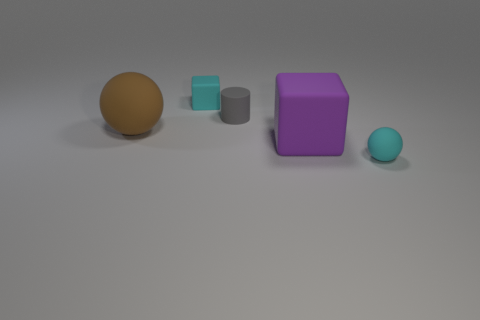There is a small cyan thing to the left of the small gray matte thing; how many gray things are to the left of it?
Give a very brief answer. 0. What number of purple things are small metallic objects or tiny matte blocks?
Offer a very short reply. 0. What is the shape of the matte object in front of the rubber block that is right of the cyan thing that is behind the large brown object?
Ensure brevity in your answer.  Sphere. There is a block that is the same size as the gray rubber object; what is its color?
Your answer should be very brief. Cyan. What number of small gray things have the same shape as the large purple object?
Keep it short and to the point. 0. Do the cyan rubber cube and the object in front of the purple matte object have the same size?
Your response must be concise. Yes. What shape is the small cyan rubber thing behind the big matte cube in front of the cyan matte block?
Provide a succinct answer. Cube. Is the number of rubber cylinders that are in front of the large rubber block less than the number of purple cubes?
Offer a very short reply. Yes. The small object that is the same color as the small matte ball is what shape?
Your answer should be very brief. Cube. How many gray rubber cylinders have the same size as the purple matte block?
Make the answer very short. 0. 